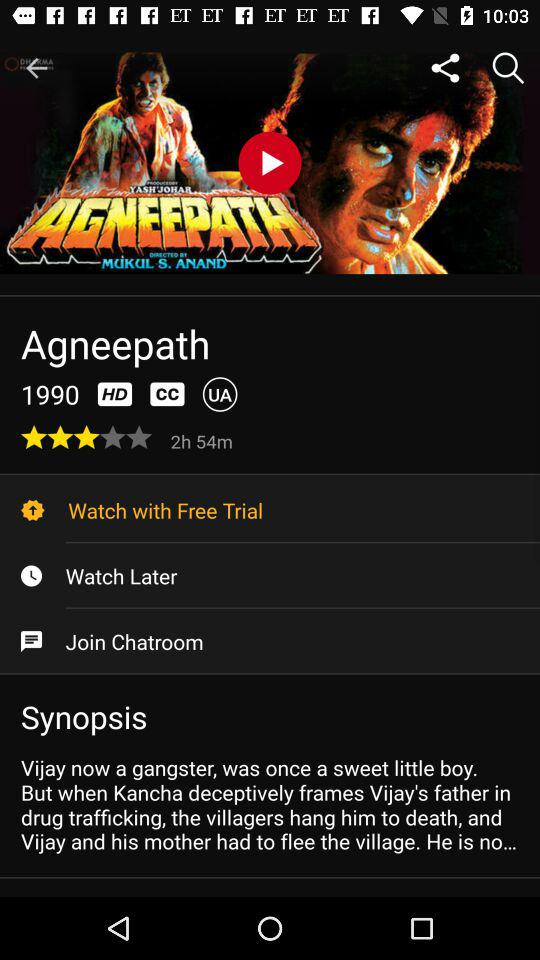What is the duration of the movie? The duration is 2 hours and 54 minutes. 